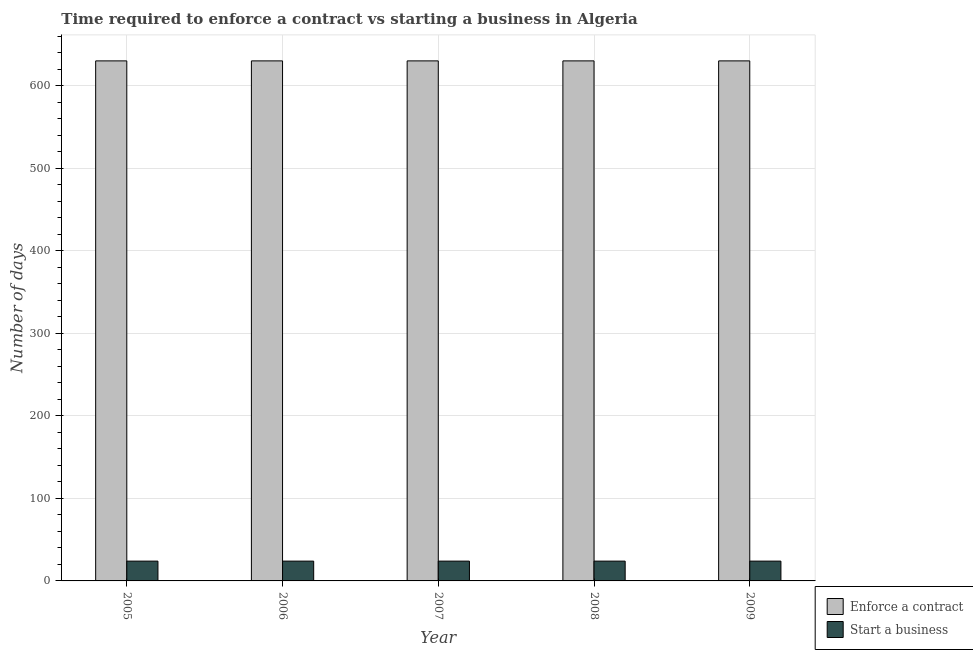How many different coloured bars are there?
Ensure brevity in your answer.  2. How many groups of bars are there?
Your answer should be very brief. 5. Are the number of bars per tick equal to the number of legend labels?
Your response must be concise. Yes. How many bars are there on the 1st tick from the left?
Offer a terse response. 2. How many bars are there on the 5th tick from the right?
Offer a very short reply. 2. What is the label of the 3rd group of bars from the left?
Your answer should be compact. 2007. What is the number of days to start a business in 2006?
Offer a terse response. 24. Across all years, what is the maximum number of days to enforece a contract?
Offer a terse response. 630. Across all years, what is the minimum number of days to enforece a contract?
Ensure brevity in your answer.  630. In which year was the number of days to start a business minimum?
Provide a short and direct response. 2005. What is the total number of days to enforece a contract in the graph?
Keep it short and to the point. 3150. What is the difference between the number of days to start a business in 2009 and the number of days to enforece a contract in 2006?
Provide a succinct answer. 0. What is the average number of days to enforece a contract per year?
Offer a terse response. 630. Is the difference between the number of days to start a business in 2006 and 2009 greater than the difference between the number of days to enforece a contract in 2006 and 2009?
Keep it short and to the point. No. What is the difference between the highest and the lowest number of days to enforece a contract?
Ensure brevity in your answer.  0. What does the 2nd bar from the left in 2005 represents?
Your answer should be compact. Start a business. What does the 2nd bar from the right in 2007 represents?
Provide a succinct answer. Enforce a contract. What is the difference between two consecutive major ticks on the Y-axis?
Provide a short and direct response. 100. Does the graph contain any zero values?
Offer a terse response. No. Where does the legend appear in the graph?
Provide a short and direct response. Bottom right. How many legend labels are there?
Offer a very short reply. 2. What is the title of the graph?
Your answer should be compact. Time required to enforce a contract vs starting a business in Algeria. What is the label or title of the Y-axis?
Give a very brief answer. Number of days. What is the Number of days in Enforce a contract in 2005?
Provide a short and direct response. 630. What is the Number of days of Enforce a contract in 2006?
Offer a terse response. 630. What is the Number of days in Enforce a contract in 2007?
Make the answer very short. 630. What is the Number of days of Enforce a contract in 2008?
Keep it short and to the point. 630. What is the Number of days in Start a business in 2008?
Provide a succinct answer. 24. What is the Number of days in Enforce a contract in 2009?
Your answer should be very brief. 630. What is the Number of days in Start a business in 2009?
Your answer should be compact. 24. Across all years, what is the maximum Number of days in Enforce a contract?
Offer a very short reply. 630. Across all years, what is the minimum Number of days of Enforce a contract?
Offer a very short reply. 630. Across all years, what is the minimum Number of days of Start a business?
Provide a succinct answer. 24. What is the total Number of days of Enforce a contract in the graph?
Your answer should be very brief. 3150. What is the total Number of days of Start a business in the graph?
Your answer should be very brief. 120. What is the difference between the Number of days in Start a business in 2005 and that in 2006?
Your response must be concise. 0. What is the difference between the Number of days in Start a business in 2005 and that in 2008?
Offer a very short reply. 0. What is the difference between the Number of days in Enforce a contract in 2006 and that in 2008?
Ensure brevity in your answer.  0. What is the difference between the Number of days of Start a business in 2006 and that in 2008?
Provide a short and direct response. 0. What is the difference between the Number of days in Enforce a contract in 2006 and that in 2009?
Your answer should be very brief. 0. What is the difference between the Number of days in Enforce a contract in 2007 and that in 2009?
Offer a very short reply. 0. What is the difference between the Number of days in Start a business in 2007 and that in 2009?
Your answer should be compact. 0. What is the difference between the Number of days in Enforce a contract in 2008 and that in 2009?
Make the answer very short. 0. What is the difference between the Number of days of Start a business in 2008 and that in 2009?
Your answer should be compact. 0. What is the difference between the Number of days of Enforce a contract in 2005 and the Number of days of Start a business in 2006?
Your response must be concise. 606. What is the difference between the Number of days in Enforce a contract in 2005 and the Number of days in Start a business in 2007?
Give a very brief answer. 606. What is the difference between the Number of days in Enforce a contract in 2005 and the Number of days in Start a business in 2008?
Make the answer very short. 606. What is the difference between the Number of days of Enforce a contract in 2005 and the Number of days of Start a business in 2009?
Give a very brief answer. 606. What is the difference between the Number of days of Enforce a contract in 2006 and the Number of days of Start a business in 2007?
Keep it short and to the point. 606. What is the difference between the Number of days of Enforce a contract in 2006 and the Number of days of Start a business in 2008?
Give a very brief answer. 606. What is the difference between the Number of days in Enforce a contract in 2006 and the Number of days in Start a business in 2009?
Ensure brevity in your answer.  606. What is the difference between the Number of days in Enforce a contract in 2007 and the Number of days in Start a business in 2008?
Ensure brevity in your answer.  606. What is the difference between the Number of days of Enforce a contract in 2007 and the Number of days of Start a business in 2009?
Make the answer very short. 606. What is the difference between the Number of days of Enforce a contract in 2008 and the Number of days of Start a business in 2009?
Ensure brevity in your answer.  606. What is the average Number of days of Enforce a contract per year?
Provide a short and direct response. 630. What is the average Number of days in Start a business per year?
Give a very brief answer. 24. In the year 2005, what is the difference between the Number of days of Enforce a contract and Number of days of Start a business?
Provide a short and direct response. 606. In the year 2006, what is the difference between the Number of days of Enforce a contract and Number of days of Start a business?
Your answer should be compact. 606. In the year 2007, what is the difference between the Number of days of Enforce a contract and Number of days of Start a business?
Ensure brevity in your answer.  606. In the year 2008, what is the difference between the Number of days in Enforce a contract and Number of days in Start a business?
Provide a succinct answer. 606. In the year 2009, what is the difference between the Number of days in Enforce a contract and Number of days in Start a business?
Provide a short and direct response. 606. What is the ratio of the Number of days of Start a business in 2005 to that in 2006?
Offer a very short reply. 1. What is the ratio of the Number of days in Start a business in 2005 to that in 2007?
Your response must be concise. 1. What is the ratio of the Number of days of Start a business in 2005 to that in 2008?
Your answer should be compact. 1. What is the ratio of the Number of days of Enforce a contract in 2006 to that in 2008?
Make the answer very short. 1. What is the ratio of the Number of days of Start a business in 2006 to that in 2008?
Provide a short and direct response. 1. What is the ratio of the Number of days of Start a business in 2006 to that in 2009?
Give a very brief answer. 1. What is the ratio of the Number of days in Enforce a contract in 2007 to that in 2009?
Give a very brief answer. 1. What is the ratio of the Number of days of Start a business in 2007 to that in 2009?
Provide a succinct answer. 1. What is the ratio of the Number of days of Enforce a contract in 2008 to that in 2009?
Offer a very short reply. 1. What is the ratio of the Number of days in Start a business in 2008 to that in 2009?
Give a very brief answer. 1. What is the difference between the highest and the second highest Number of days of Start a business?
Give a very brief answer. 0. 